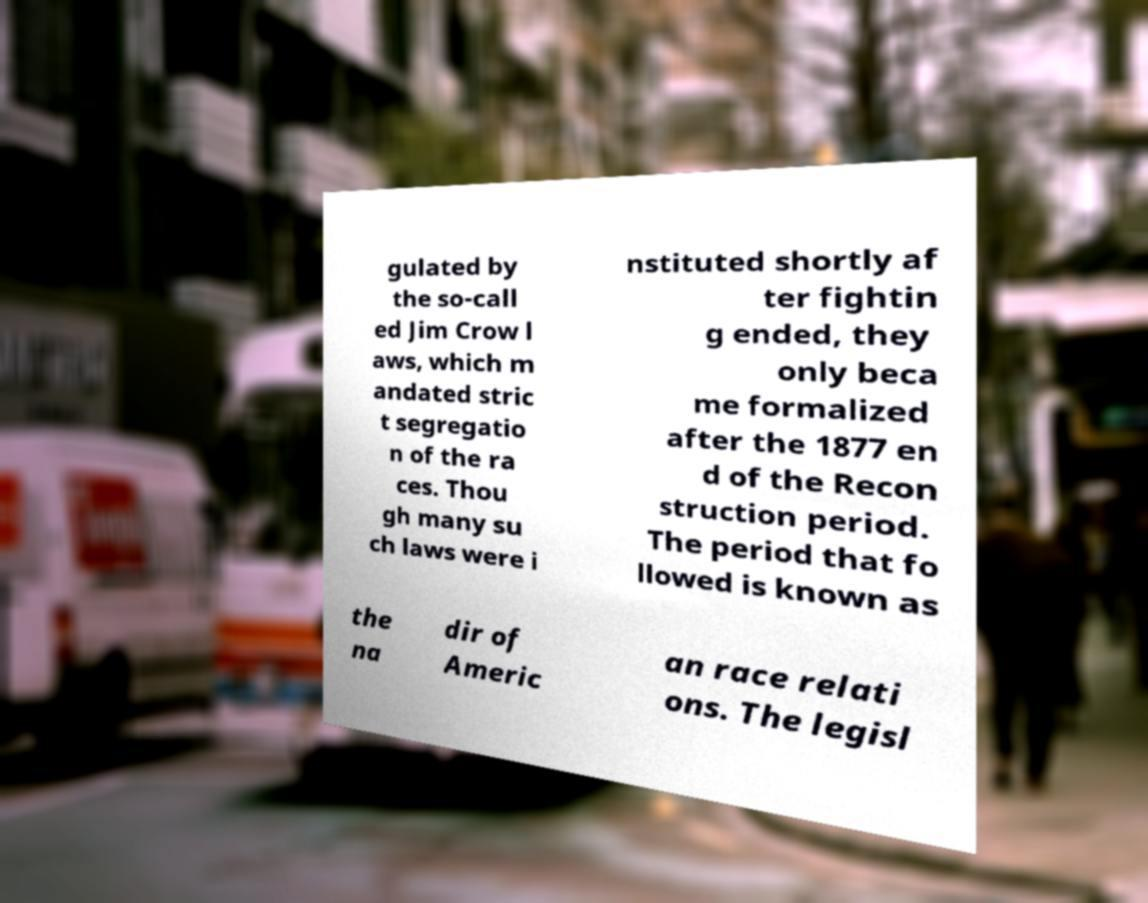There's text embedded in this image that I need extracted. Can you transcribe it verbatim? gulated by the so-call ed Jim Crow l aws, which m andated stric t segregatio n of the ra ces. Thou gh many su ch laws were i nstituted shortly af ter fightin g ended, they only beca me formalized after the 1877 en d of the Recon struction period. The period that fo llowed is known as the na dir of Americ an race relati ons. The legisl 